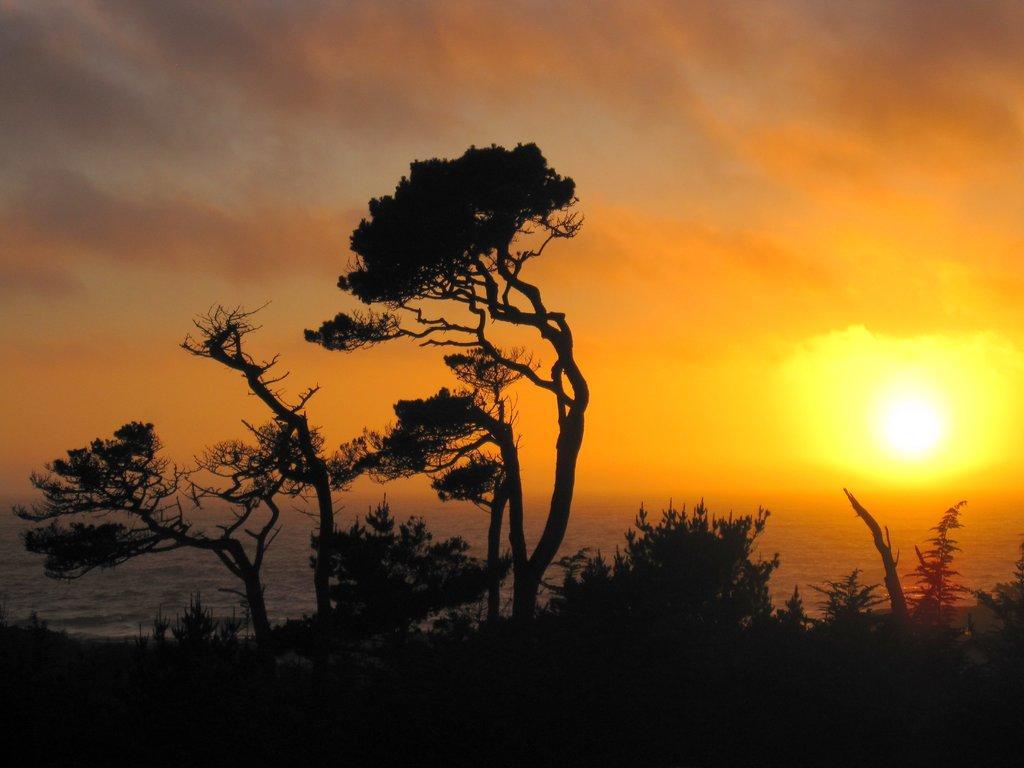Please provide a concise description of this image. In this image, we can see some trees, we can see the water and the sunset. 